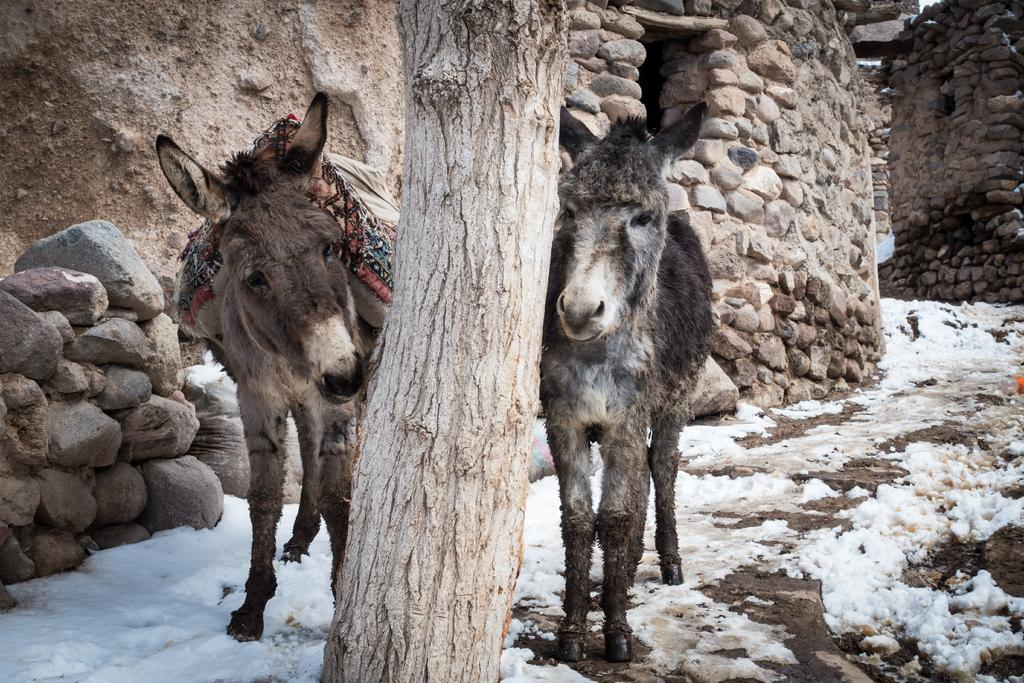How many donkeys are present in the image? There are two donkeys in the image. What is the donkeys' location in relation to the wall? The donkeys are standing beside a wall made of stones. What is between the two donkeys? There is a tree trunk between the donkeys. What type of surface are the donkeys standing on? The donkeys are standing on land covered with ice. What organization is responsible for the observation of the donkeys in the image? There is no organization mentioned or implied in the image, and no one is observing the donkeys. 